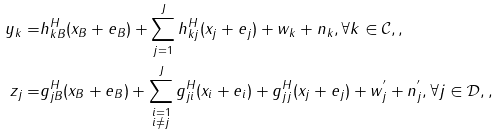Convert formula to latex. <formula><loc_0><loc_0><loc_500><loc_500>y _ { k } = & h _ { k B } ^ { H } ( { x } _ { B } + { e } _ { B } ) + \sum _ { j = 1 } ^ { J } { h } _ { k j } ^ { H } ( { x } _ { j } + { e } _ { j } ) + w _ { k } + n _ { k } , \forall k \in \mathcal { C } , , \\ z _ { j } = & { g } _ { j B } ^ { H } ( { x } _ { B } + { e } _ { B } ) + \sum _ { \substack { i = 1 \\ i \neq j } } ^ { J } { g } _ { j i } ^ { H } ( { x } _ { i } + { e } _ { i } ) + { g } _ { j j } ^ { H } ( { x } _ { j } + { e } _ { j } ) + w ^ { ^ { \prime } } _ { j } + n ^ { ^ { \prime } } _ { j } , \forall j \in \mathcal { D } , ,</formula> 